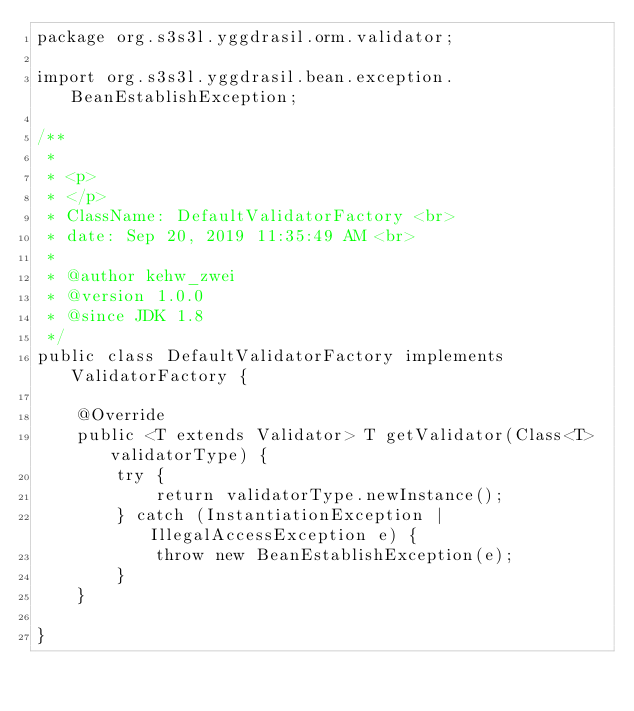<code> <loc_0><loc_0><loc_500><loc_500><_Java_>package org.s3s3l.yggdrasil.orm.validator;

import org.s3s3l.yggdrasil.bean.exception.BeanEstablishException;

/**
 * 
 * <p>
 * </p>
 * ClassName: DefaultValidatorFactory <br>
 * date: Sep 20, 2019 11:35:49 AM <br>
 * 
 * @author kehw_zwei
 * @version 1.0.0
 * @since JDK 1.8
 */
public class DefaultValidatorFactory implements ValidatorFactory {

    @Override
    public <T extends Validator> T getValidator(Class<T> validatorType) {
        try {
            return validatorType.newInstance();
        } catch (InstantiationException | IllegalAccessException e) {
            throw new BeanEstablishException(e);
        }
    }

}
</code> 